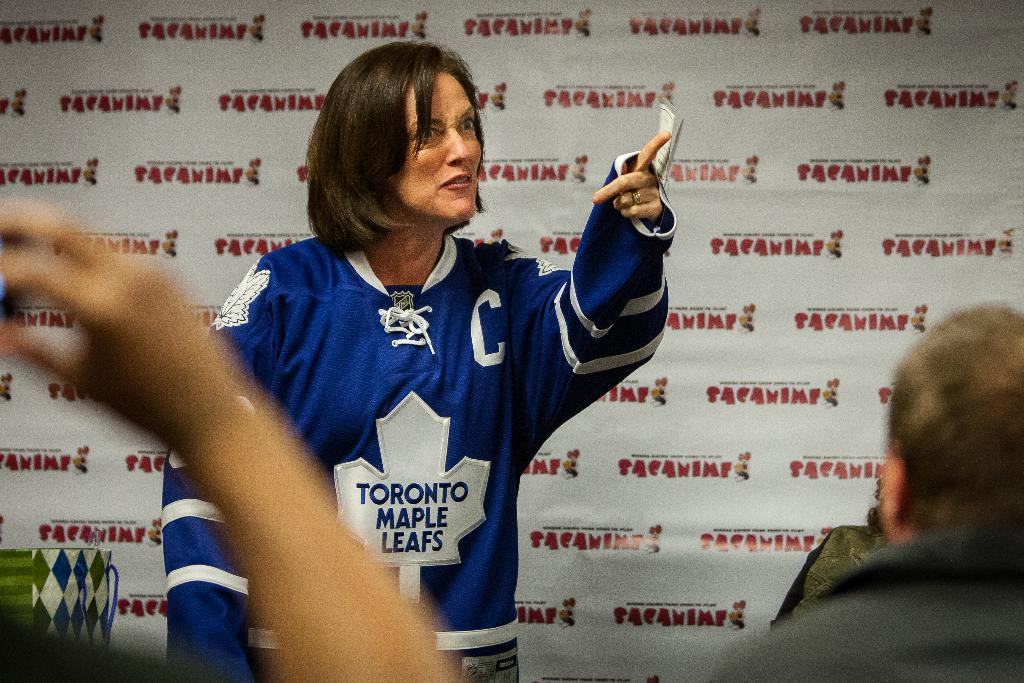Provide a one-sentence caption for the provided image. A woman wearing a Toronto Maple Leafs jersey stands and points into an audience. 